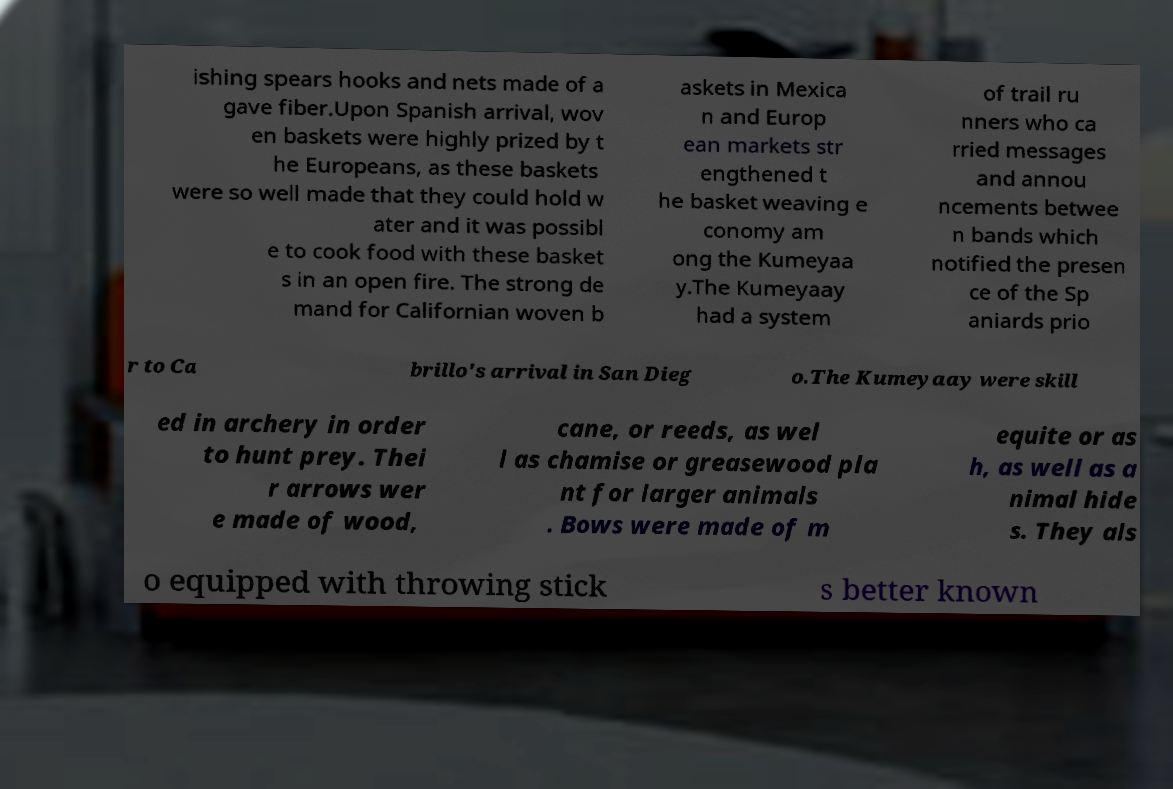Please read and relay the text visible in this image. What does it say? ishing spears hooks and nets made of a gave fiber.Upon Spanish arrival, wov en baskets were highly prized by t he Europeans, as these baskets were so well made that they could hold w ater and it was possibl e to cook food with these basket s in an open fire. The strong de mand for Californian woven b askets in Mexica n and Europ ean markets str engthened t he basket weaving e conomy am ong the Kumeyaa y.The Kumeyaay had a system of trail ru nners who ca rried messages and annou ncements betwee n bands which notified the presen ce of the Sp aniards prio r to Ca brillo's arrival in San Dieg o.The Kumeyaay were skill ed in archery in order to hunt prey. Thei r arrows wer e made of wood, cane, or reeds, as wel l as chamise or greasewood pla nt for larger animals . Bows were made of m equite or as h, as well as a nimal hide s. They als o equipped with throwing stick s better known 